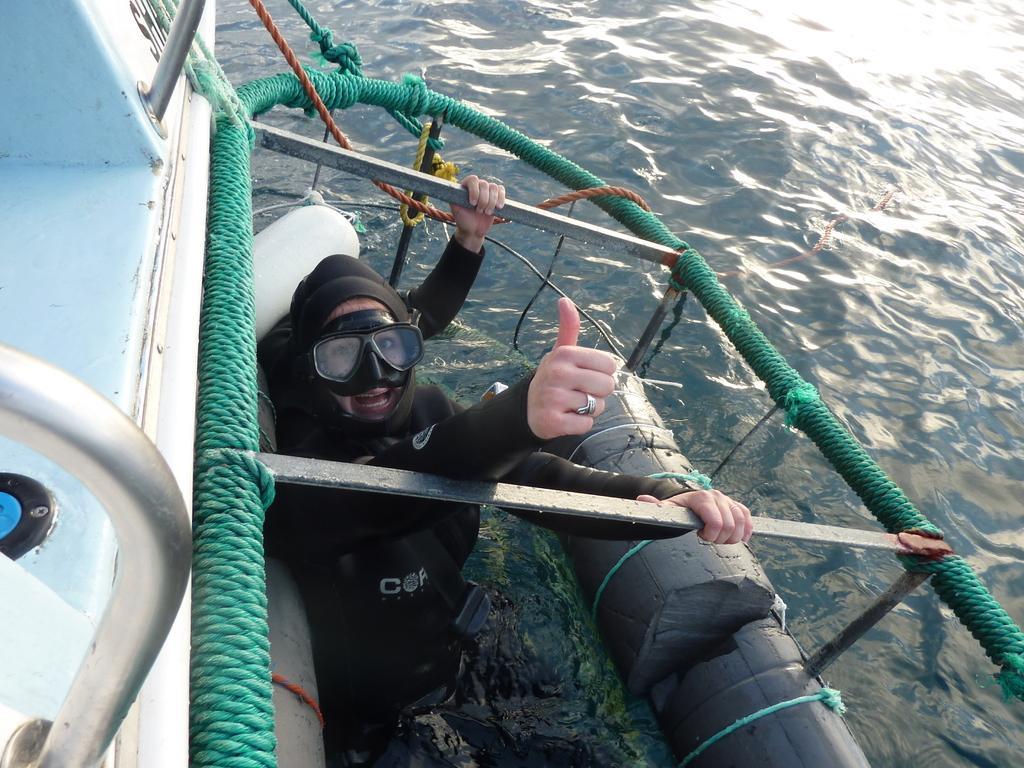Could you give a brief overview of what you see in this image? In the center of the image we can see a person in water. On the left side of the image we can see a boat. In the background there is a water. 